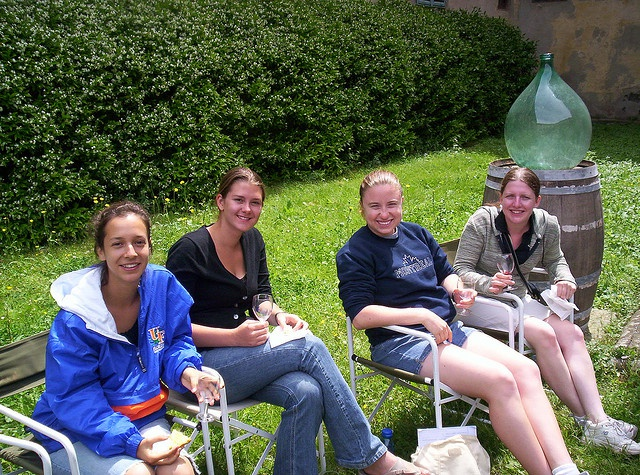Describe the objects in this image and their specific colors. I can see people in gray, darkblue, blue, white, and navy tones, people in gray, white, black, lightpink, and brown tones, people in gray, black, navy, darkblue, and brown tones, people in gray, lavender, darkgray, and black tones, and chair in gray, black, white, and darkgreen tones in this image. 